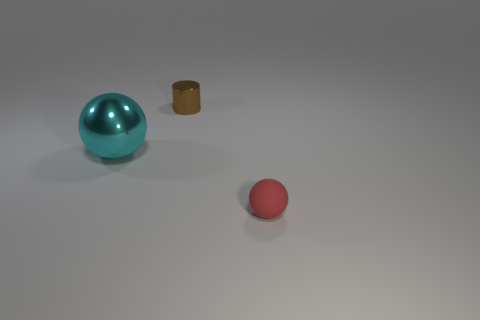Subtract all red balls. How many balls are left? 1 Add 2 matte blocks. How many objects exist? 5 Subtract all cylinders. How many objects are left? 2 Subtract 1 spheres. How many spheres are left? 1 Subtract 0 green blocks. How many objects are left? 3 Subtract all purple cylinders. Subtract all brown balls. How many cylinders are left? 1 Subtract all green cylinders. How many red spheres are left? 1 Subtract all brown balls. Subtract all big cyan shiny balls. How many objects are left? 2 Add 2 shiny objects. How many shiny objects are left? 4 Add 1 small brown metallic cylinders. How many small brown metallic cylinders exist? 2 